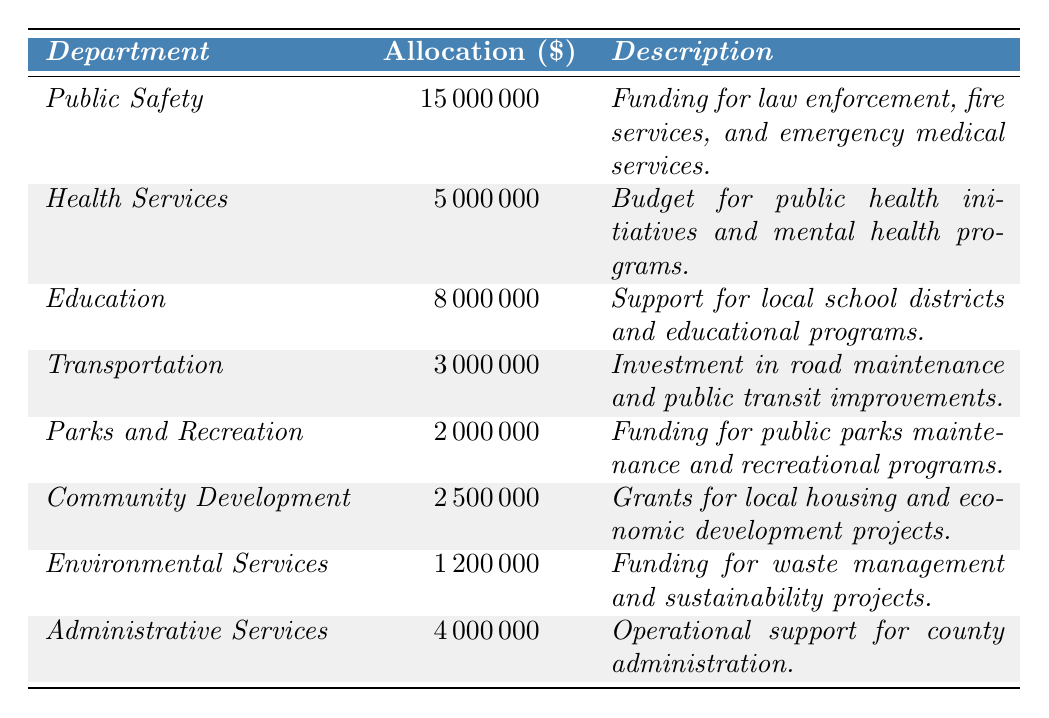What is the allocation for Public Safety? The table indicates that the allocation for the Public Safety department is listed directly under the allocation column. It shows 15,000,000 dollars.
Answer: 15,000,000 Which department has the lowest allocation? By examining the allocation amounts in the table, Environmental Services has the lowest allocation at 1,200,000 dollars.
Answer: Environmental Services What is the total allocation for Education and Health Services combined? The allocation for Education is 8,000,000 and for Health Services is 5,000,000. Adding these two gives us 8,000,000 + 5,000,000 = 13,000,000 dollars.
Answer: 13,000,000 Is the allocation for Transportation higher than that for Parks and Recreation? Transportation has an allocation of 3,000,000 dollars, while Parks and Recreation has 2,000,000 dollars. Since 3,000,000 is greater than 2,000,000, the statement is true.
Answer: Yes What is the combined total budget allocation for Community Development and Environmental Services? Community Development has 2,500,000 and Environmental Services has 1,200,000. Adding these together, 2,500,000 + 1,200,000 equals 3,700,000 dollars in total allocation.
Answer: 3,700,000 How much more is allocated to Public Safety than to Administrative Services? Public Safety's allocation is 15,000,000 and Administrative Services' allocation is 4,000,000. The difference is 15,000,000 - 4,000,000 = 11,000,000 dollars.
Answer: 11,000,000 Which department has a higher allocation: Education or Health Services? Education has an allocation of 8,000,000 dollars compared to Health Services, which has 5,000,000 dollars. Since 8,000,000 is greater than 5,000,000, Education has the higher allocation.
Answer: Education What is the average budget allocation for all departments listed? The total allocation across all departments is 34,000,000 dollars (sum of all allocations), and there are 8 departments. Therefore, the average allocation is 34,000,000 / 8 = 4,250,000 dollars.
Answer: 4,250,000 Is the funding for Health Services specifically supporting COVID-19 response efforts? The notes section for Health Services indicates that it includes funding for COVID-19 response efforts, thus confirming the fact.
Answer: Yes What percentage of the total budget is allocated to Public Safety? Total allocation is 34,000,000 and Public Safety's allocation is 15,000,000. The percentage is (15,000,000 / 34,000,000) * 100 = approximately 44.12%.
Answer: 44.12% 